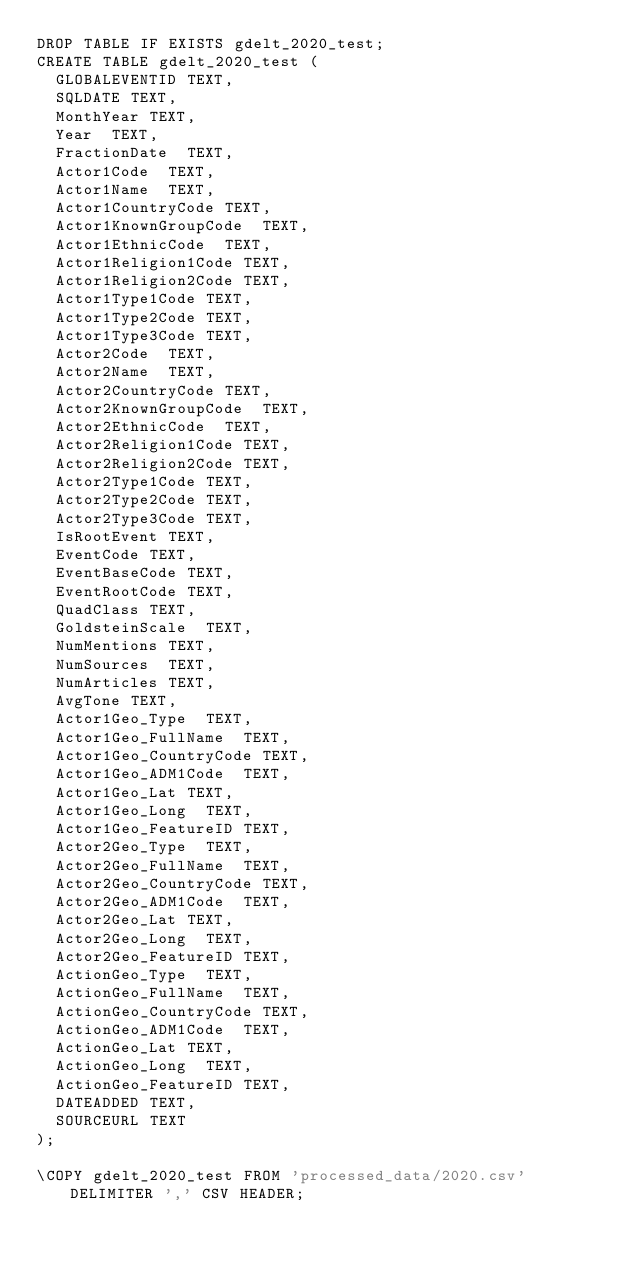Convert code to text. <code><loc_0><loc_0><loc_500><loc_500><_SQL_>DROP TABLE IF EXISTS gdelt_2020_test;
CREATE TABLE gdelt_2020_test (
  GLOBALEVENTID TEXT,
  SQLDATE TEXT,
  MonthYear TEXT,
  Year  TEXT,
  FractionDate  TEXT,
  Actor1Code  TEXT,
  Actor1Name  TEXT,
  Actor1CountryCode TEXT,
  Actor1KnownGroupCode  TEXT,
  Actor1EthnicCode  TEXT,
  Actor1Religion1Code TEXT,
  Actor1Religion2Code TEXT,
  Actor1Type1Code TEXT,
  Actor1Type2Code TEXT,
  Actor1Type3Code TEXT,
  Actor2Code  TEXT,
  Actor2Name  TEXT,
  Actor2CountryCode TEXT,
  Actor2KnownGroupCode  TEXT,
  Actor2EthnicCode  TEXT,
  Actor2Religion1Code TEXT,
  Actor2Religion2Code TEXT,
  Actor2Type1Code TEXT,
  Actor2Type2Code TEXT,
  Actor2Type3Code TEXT,
  IsRootEvent TEXT,
  EventCode TEXT,
  EventBaseCode TEXT,
  EventRootCode TEXT,
  QuadClass TEXT,
  GoldsteinScale  TEXT,
  NumMentions TEXT,
  NumSources  TEXT,
  NumArticles TEXT,
  AvgTone TEXT,
  Actor1Geo_Type  TEXT,
  Actor1Geo_FullName  TEXT,
  Actor1Geo_CountryCode TEXT,
  Actor1Geo_ADM1Code  TEXT,
  Actor1Geo_Lat TEXT,
  Actor1Geo_Long  TEXT,
  Actor1Geo_FeatureID TEXT,
  Actor2Geo_Type  TEXT,
  Actor2Geo_FullName  TEXT,
  Actor2Geo_CountryCode TEXT,
  Actor2Geo_ADM1Code  TEXT,
  Actor2Geo_Lat TEXT,
  Actor2Geo_Long  TEXT,
  Actor2Geo_FeatureID TEXT,
  ActionGeo_Type  TEXT,
  ActionGeo_FullName  TEXT,
  ActionGeo_CountryCode TEXT,
  ActionGeo_ADM1Code  TEXT,
  ActionGeo_Lat TEXT,
  ActionGeo_Long  TEXT,
  ActionGeo_FeatureID TEXT,
  DATEADDED TEXT,
  SOURCEURL TEXT
);

\COPY gdelt_2020_test FROM 'processed_data/2020.csv' DELIMITER ',' CSV HEADER;
</code> 